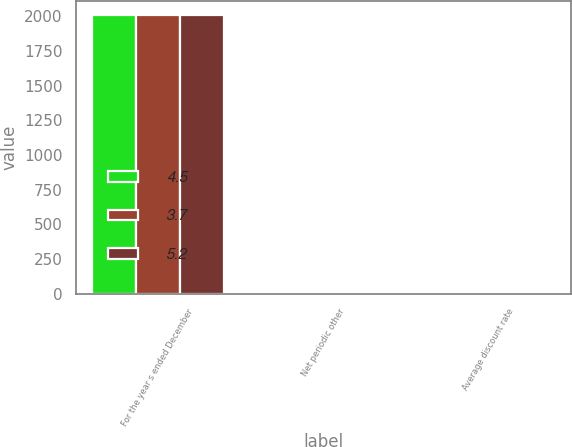Convert chart. <chart><loc_0><loc_0><loc_500><loc_500><stacked_bar_chart><ecel><fcel>For the year s ended December<fcel>Net periodic other<fcel>Average discount rate<nl><fcel>4.5<fcel>2013<fcel>12.5<fcel>3.7<nl><fcel>3.7<fcel>2012<fcel>15.1<fcel>4.5<nl><fcel>5.2<fcel>2011<fcel>16.2<fcel>5.2<nl></chart> 